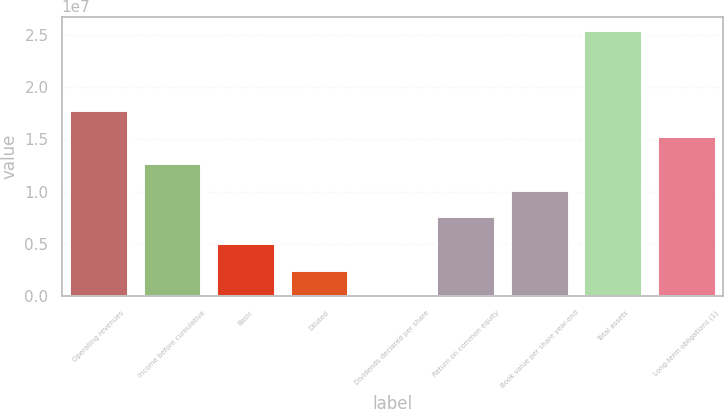Convert chart to OTSL. <chart><loc_0><loc_0><loc_500><loc_500><bar_chart><fcel>Operating revenues<fcel>Income before cumulative<fcel>Basic<fcel>Diluted<fcel>Dividends declared per share<fcel>Return on common equity<fcel>Book value per share year-end<fcel>Total assets<fcel>Long-term obligations (1)<nl><fcel>1.78163e+07<fcel>1.27259e+07<fcel>5.09038e+06<fcel>2.54519e+06<fcel>1.22<fcel>7.63557e+06<fcel>1.01808e+07<fcel>2.54519e+07<fcel>1.52711e+07<nl></chart> 